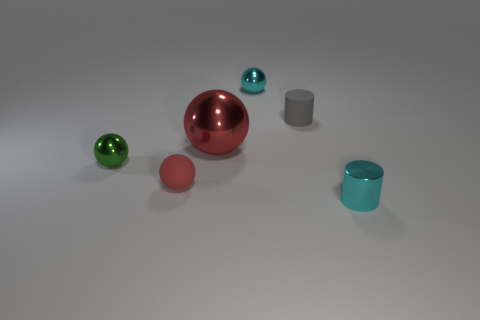Subtract all red cylinders. How many red spheres are left? 2 Subtract all small spheres. How many spheres are left? 1 Subtract all cyan balls. How many balls are left? 3 Add 2 tiny cylinders. How many objects exist? 8 Subtract all yellow spheres. Subtract all red cylinders. How many spheres are left? 4 Add 4 cylinders. How many cylinders are left? 6 Add 4 cylinders. How many cylinders exist? 6 Subtract 0 purple cylinders. How many objects are left? 6 Subtract all balls. How many objects are left? 2 Subtract all green cylinders. Subtract all rubber spheres. How many objects are left? 5 